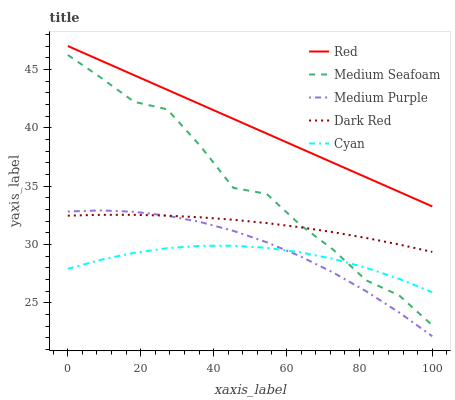Does Dark Red have the minimum area under the curve?
Answer yes or no. No. Does Dark Red have the maximum area under the curve?
Answer yes or no. No. Is Dark Red the smoothest?
Answer yes or no. No. Is Dark Red the roughest?
Answer yes or no. No. Does Dark Red have the lowest value?
Answer yes or no. No. Does Dark Red have the highest value?
Answer yes or no. No. Is Cyan less than Red?
Answer yes or no. Yes. Is Red greater than Medium Purple?
Answer yes or no. Yes. Does Cyan intersect Red?
Answer yes or no. No. 